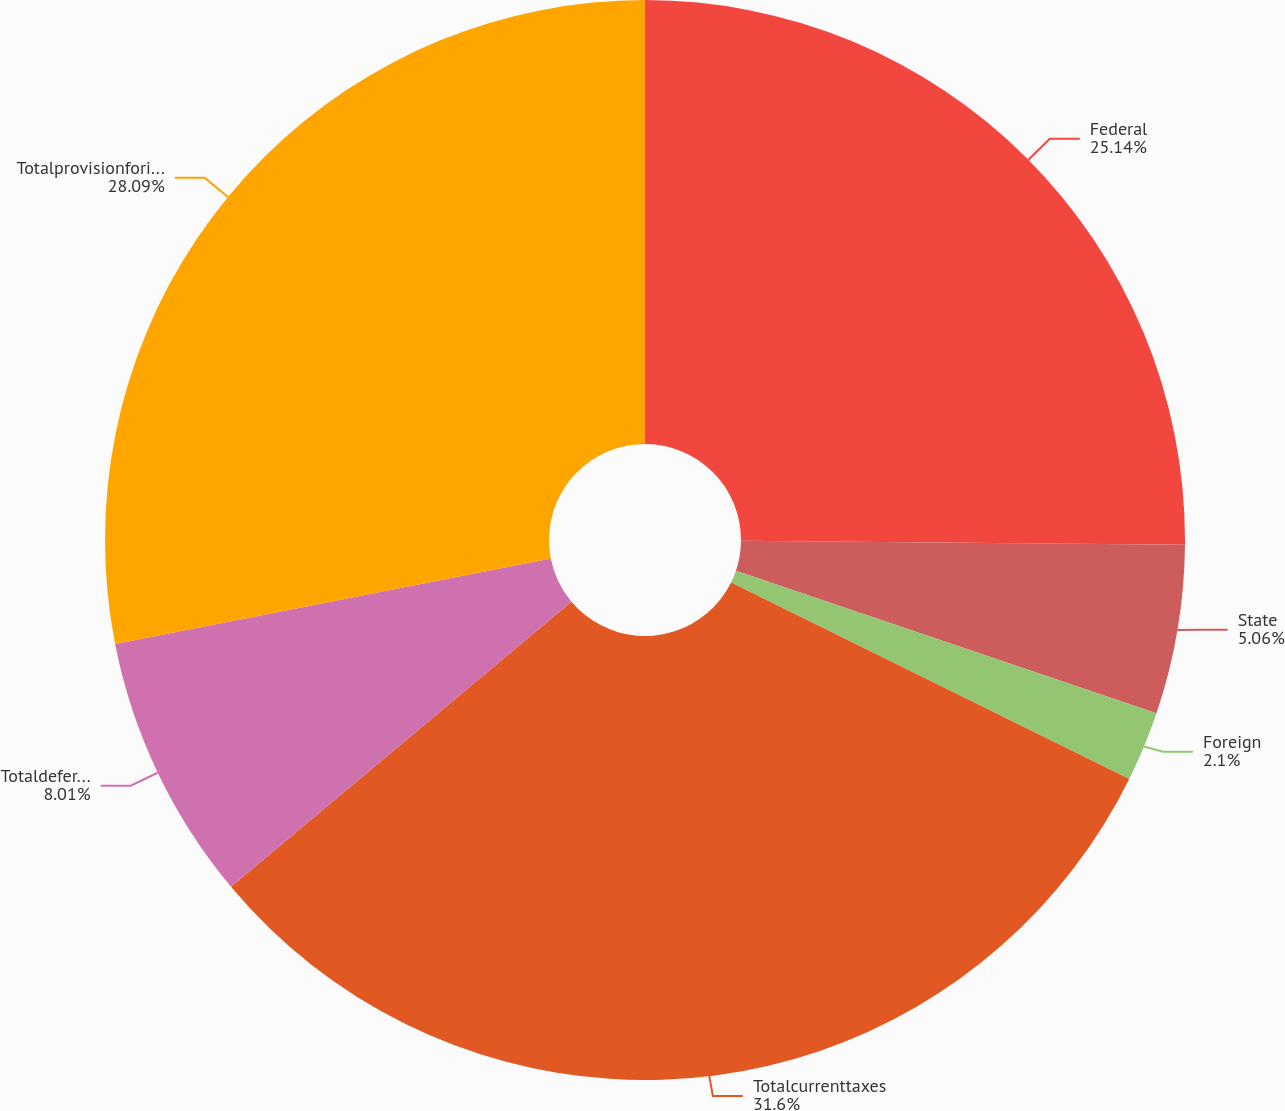Convert chart. <chart><loc_0><loc_0><loc_500><loc_500><pie_chart><fcel>Federal<fcel>State<fcel>Foreign<fcel>Totalcurrenttaxes<fcel>Totaldeferredtaxes<fcel>Totalprovisionforincometaxes<nl><fcel>25.14%<fcel>5.06%<fcel>2.1%<fcel>31.61%<fcel>8.01%<fcel>28.09%<nl></chart> 